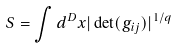Convert formula to latex. <formula><loc_0><loc_0><loc_500><loc_500>S = \int d ^ { D } x | \det ( g _ { i j } ) | ^ { 1 / q }</formula> 